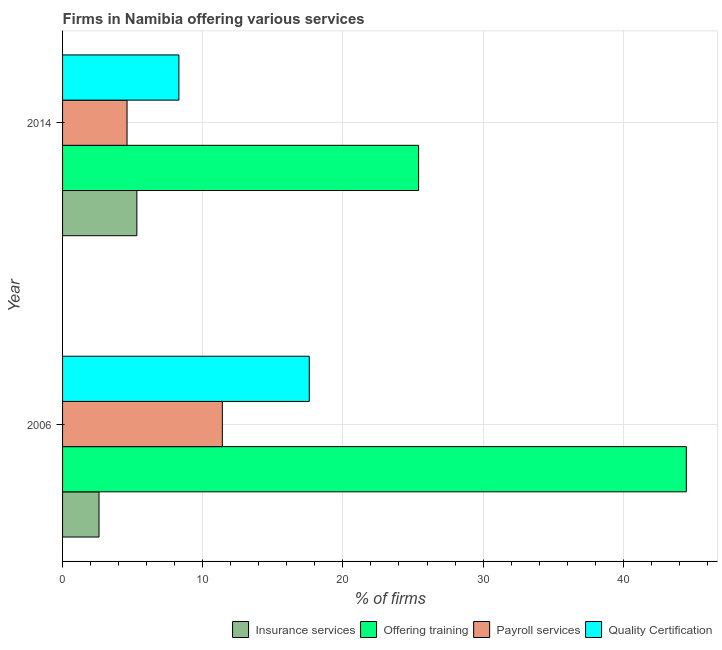How many different coloured bars are there?
Your response must be concise. 4. How many groups of bars are there?
Keep it short and to the point. 2. How many bars are there on the 1st tick from the top?
Make the answer very short. 4. How many bars are there on the 2nd tick from the bottom?
Your answer should be compact. 4. What is the label of the 1st group of bars from the top?
Your response must be concise. 2014. What is the percentage of firms offering training in 2014?
Keep it short and to the point. 25.4. Across all years, what is the maximum percentage of firms offering training?
Offer a very short reply. 44.5. Across all years, what is the minimum percentage of firms offering training?
Keep it short and to the point. 25.4. In which year was the percentage of firms offering insurance services maximum?
Keep it short and to the point. 2014. What is the total percentage of firms offering quality certification in the graph?
Ensure brevity in your answer.  25.9. What is the difference between the percentage of firms offering quality certification in 2006 and that in 2014?
Offer a terse response. 9.3. What is the difference between the percentage of firms offering training in 2014 and the percentage of firms offering payroll services in 2006?
Your response must be concise. 14. What is the average percentage of firms offering insurance services per year?
Offer a terse response. 3.95. In the year 2006, what is the difference between the percentage of firms offering payroll services and percentage of firms offering insurance services?
Your answer should be very brief. 8.8. What is the ratio of the percentage of firms offering payroll services in 2006 to that in 2014?
Your response must be concise. 2.48. Is the percentage of firms offering quality certification in 2006 less than that in 2014?
Offer a terse response. No. Is it the case that in every year, the sum of the percentage of firms offering quality certification and percentage of firms offering payroll services is greater than the sum of percentage of firms offering insurance services and percentage of firms offering training?
Make the answer very short. No. What does the 3rd bar from the top in 2006 represents?
Keep it short and to the point. Offering training. What does the 1st bar from the bottom in 2006 represents?
Give a very brief answer. Insurance services. How many years are there in the graph?
Your answer should be very brief. 2. Are the values on the major ticks of X-axis written in scientific E-notation?
Your answer should be compact. No. Does the graph contain any zero values?
Your answer should be very brief. No. Where does the legend appear in the graph?
Your answer should be compact. Bottom right. How many legend labels are there?
Provide a short and direct response. 4. What is the title of the graph?
Provide a short and direct response. Firms in Namibia offering various services . Does "Germany" appear as one of the legend labels in the graph?
Give a very brief answer. No. What is the label or title of the X-axis?
Your response must be concise. % of firms. What is the label or title of the Y-axis?
Offer a very short reply. Year. What is the % of firms in Offering training in 2006?
Offer a very short reply. 44.5. What is the % of firms in Quality Certification in 2006?
Keep it short and to the point. 17.6. What is the % of firms of Offering training in 2014?
Keep it short and to the point. 25.4. What is the % of firms of Payroll services in 2014?
Provide a succinct answer. 4.6. What is the % of firms of Quality Certification in 2014?
Your response must be concise. 8.3. Across all years, what is the maximum % of firms of Insurance services?
Provide a short and direct response. 5.3. Across all years, what is the maximum % of firms in Offering training?
Offer a very short reply. 44.5. Across all years, what is the maximum % of firms of Quality Certification?
Offer a terse response. 17.6. Across all years, what is the minimum % of firms of Insurance services?
Provide a succinct answer. 2.6. Across all years, what is the minimum % of firms of Offering training?
Your response must be concise. 25.4. Across all years, what is the minimum % of firms in Quality Certification?
Offer a terse response. 8.3. What is the total % of firms of Offering training in the graph?
Provide a succinct answer. 69.9. What is the total % of firms in Quality Certification in the graph?
Your response must be concise. 25.9. What is the difference between the % of firms in Quality Certification in 2006 and that in 2014?
Your answer should be very brief. 9.3. What is the difference between the % of firms of Insurance services in 2006 and the % of firms of Offering training in 2014?
Ensure brevity in your answer.  -22.8. What is the difference between the % of firms in Offering training in 2006 and the % of firms in Payroll services in 2014?
Provide a short and direct response. 39.9. What is the difference between the % of firms in Offering training in 2006 and the % of firms in Quality Certification in 2014?
Offer a very short reply. 36.2. What is the difference between the % of firms in Payroll services in 2006 and the % of firms in Quality Certification in 2014?
Make the answer very short. 3.1. What is the average % of firms of Insurance services per year?
Make the answer very short. 3.95. What is the average % of firms in Offering training per year?
Give a very brief answer. 34.95. What is the average % of firms in Payroll services per year?
Offer a terse response. 8. What is the average % of firms of Quality Certification per year?
Your response must be concise. 12.95. In the year 2006, what is the difference between the % of firms of Insurance services and % of firms of Offering training?
Offer a terse response. -41.9. In the year 2006, what is the difference between the % of firms in Insurance services and % of firms in Payroll services?
Offer a very short reply. -8.8. In the year 2006, what is the difference between the % of firms of Insurance services and % of firms of Quality Certification?
Offer a very short reply. -15. In the year 2006, what is the difference between the % of firms in Offering training and % of firms in Payroll services?
Make the answer very short. 33.1. In the year 2006, what is the difference between the % of firms of Offering training and % of firms of Quality Certification?
Your answer should be compact. 26.9. In the year 2006, what is the difference between the % of firms of Payroll services and % of firms of Quality Certification?
Offer a very short reply. -6.2. In the year 2014, what is the difference between the % of firms in Insurance services and % of firms in Offering training?
Keep it short and to the point. -20.1. In the year 2014, what is the difference between the % of firms in Insurance services and % of firms in Quality Certification?
Your response must be concise. -3. In the year 2014, what is the difference between the % of firms in Offering training and % of firms in Payroll services?
Your response must be concise. 20.8. In the year 2014, what is the difference between the % of firms in Offering training and % of firms in Quality Certification?
Your answer should be very brief. 17.1. What is the ratio of the % of firms of Insurance services in 2006 to that in 2014?
Offer a very short reply. 0.49. What is the ratio of the % of firms in Offering training in 2006 to that in 2014?
Make the answer very short. 1.75. What is the ratio of the % of firms in Payroll services in 2006 to that in 2014?
Give a very brief answer. 2.48. What is the ratio of the % of firms of Quality Certification in 2006 to that in 2014?
Your response must be concise. 2.12. What is the difference between the highest and the second highest % of firms in Quality Certification?
Your answer should be very brief. 9.3. What is the difference between the highest and the lowest % of firms in Insurance services?
Give a very brief answer. 2.7. 